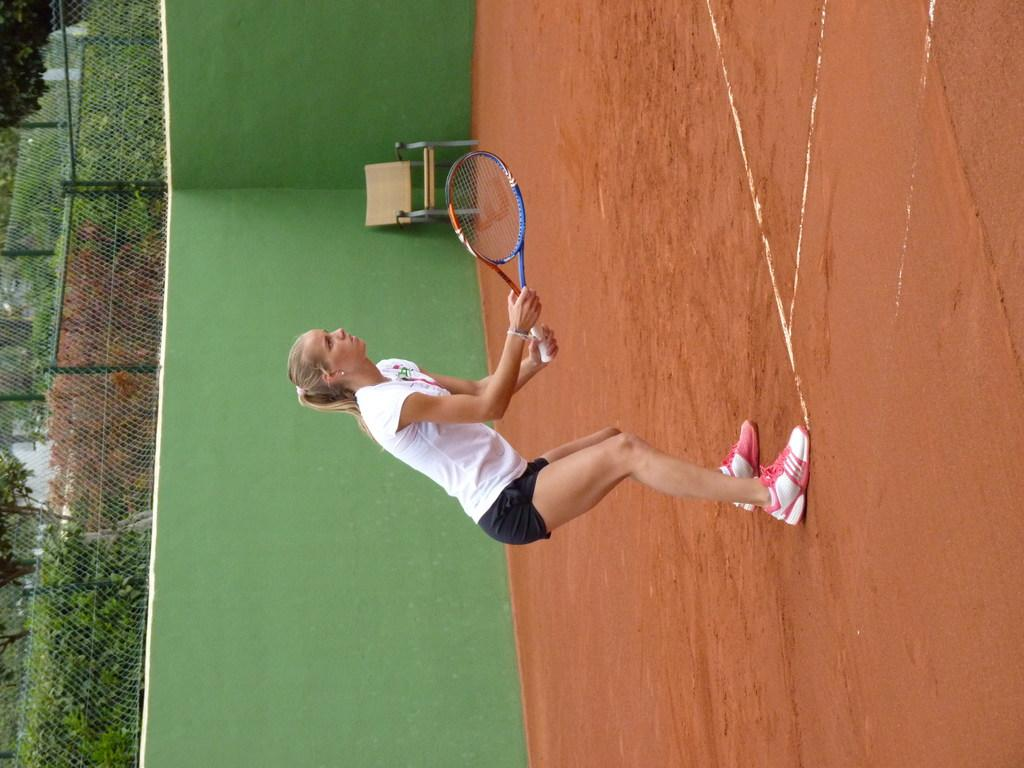Who is present in the image? There is a woman in the image. What is the woman holding in the image? The woman is holding a bat. What is the woman wearing in the image? The woman is wearing a white t-shirt. Where is the woman standing in the image? The woman is standing on the ground. What can be seen on the left side of the image? There is a green color wall on the left side of the image. What structures are present in the image? There is a fence in the image. What type of vegetation is present in the image? There are bushes in the image. What type of bag does the woman have an idea about in the image? There is no bag or mention of an idea in the image; the woman is holding a bat and standing on the ground. 